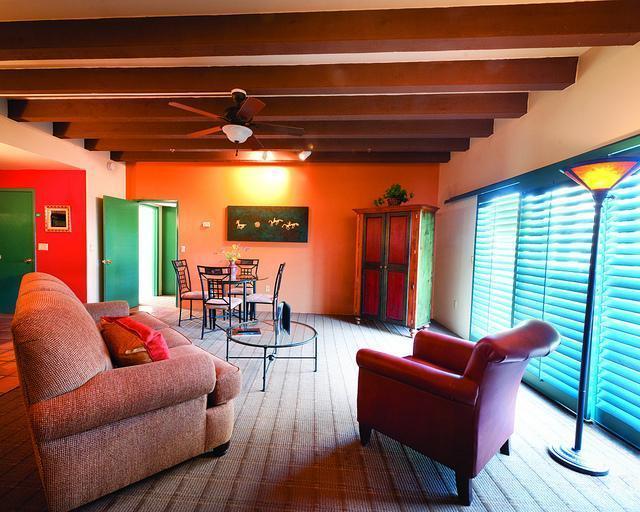How many hands does the man have?
Give a very brief answer. 0. 